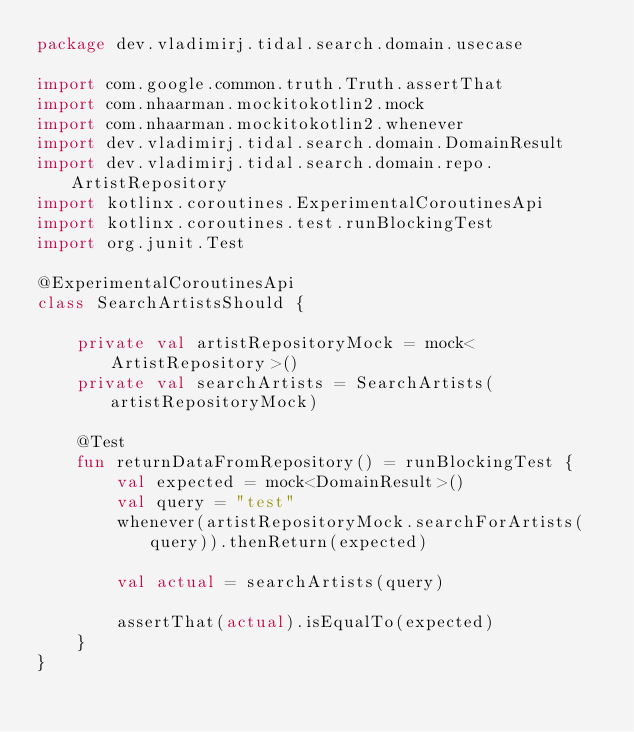Convert code to text. <code><loc_0><loc_0><loc_500><loc_500><_Kotlin_>package dev.vladimirj.tidal.search.domain.usecase

import com.google.common.truth.Truth.assertThat
import com.nhaarman.mockitokotlin2.mock
import com.nhaarman.mockitokotlin2.whenever
import dev.vladimirj.tidal.search.domain.DomainResult
import dev.vladimirj.tidal.search.domain.repo.ArtistRepository
import kotlinx.coroutines.ExperimentalCoroutinesApi
import kotlinx.coroutines.test.runBlockingTest
import org.junit.Test

@ExperimentalCoroutinesApi
class SearchArtistsShould {

    private val artistRepositoryMock = mock<ArtistRepository>()
    private val searchArtists = SearchArtists(artistRepositoryMock)

    @Test
    fun returnDataFromRepository() = runBlockingTest {
        val expected = mock<DomainResult>()
        val query = "test"
        whenever(artistRepositoryMock.searchForArtists(query)).thenReturn(expected)

        val actual = searchArtists(query)

        assertThat(actual).isEqualTo(expected)
    }
}</code> 